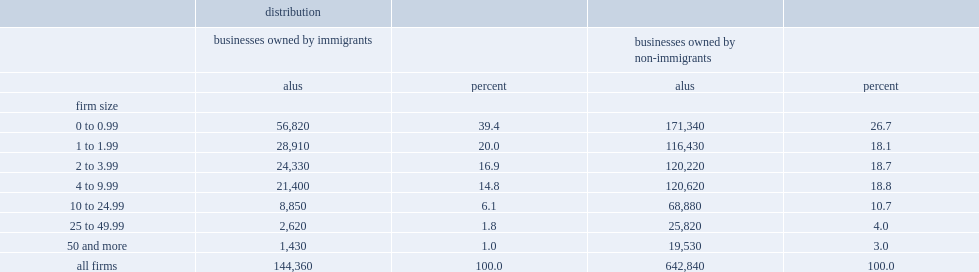What the percent of immigrant-owned private businesses with 10 or more employees? 8.9. What the percent of businesses employed fewer than 2 people among the comparison group in 2010? 44.8. What the percent of businesses employed 2 to 10 employees among the comparison group in 2010? 37.5. What the percent of businesses employed more than 10 employees among the comparison group in 2010? 17.7. 